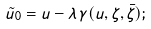<formula> <loc_0><loc_0><loc_500><loc_500>\tilde { u } _ { 0 } = u - \lambda \, \gamma ( u , \zeta , \bar { \zeta } ) ;</formula> 